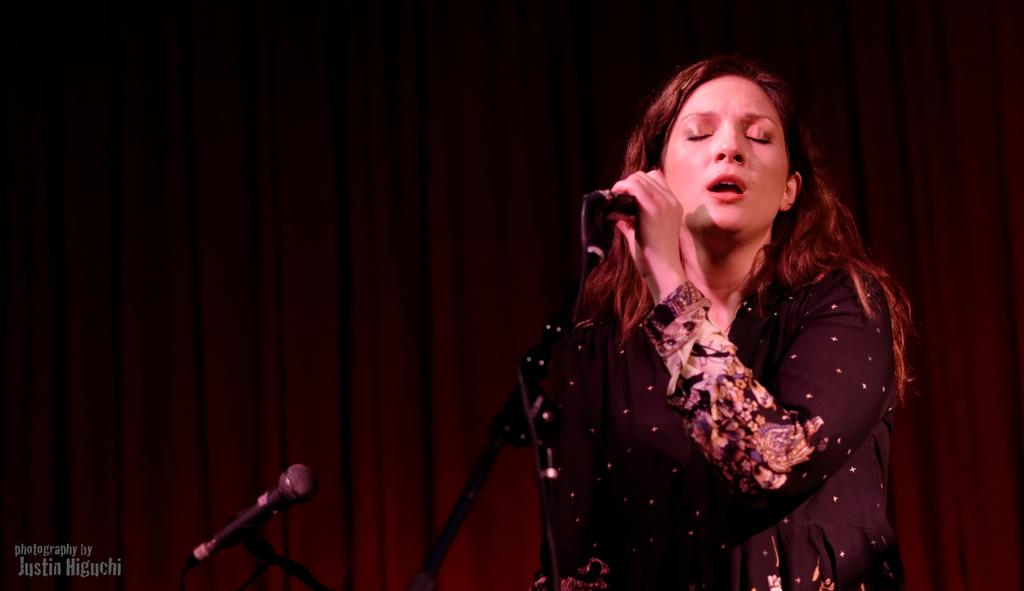Who is the main subject in the image? There is a woman in the image. What is the woman holding in her hand? The woman is holding a mic in her hand. Can you describe the background of the image? There is another mic visible in the background of the image. What type of bread can be seen on the moon in the image? There is no bread or moon present in the image; it features a woman holding a mic and another mic in the background. 